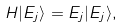<formula> <loc_0><loc_0><loc_500><loc_500>H | E _ { j } \rangle = E _ { j } | E _ { j } \rangle ,</formula> 